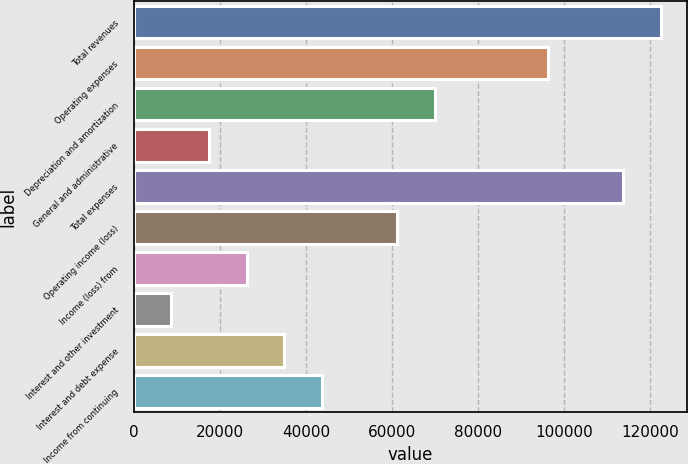Convert chart. <chart><loc_0><loc_0><loc_500><loc_500><bar_chart><fcel>Total revenues<fcel>Operating expenses<fcel>Depreciation and amortization<fcel>General and administrative<fcel>Total expenses<fcel>Operating income (loss)<fcel>Income (loss) from<fcel>Interest and other investment<fcel>Interest and debt expense<fcel>Income from continuing<nl><fcel>122397<fcel>96170.2<fcel>69943.6<fcel>17490.3<fcel>113655<fcel>61201.4<fcel>26232.5<fcel>8748.11<fcel>34974.7<fcel>43716.9<nl></chart> 